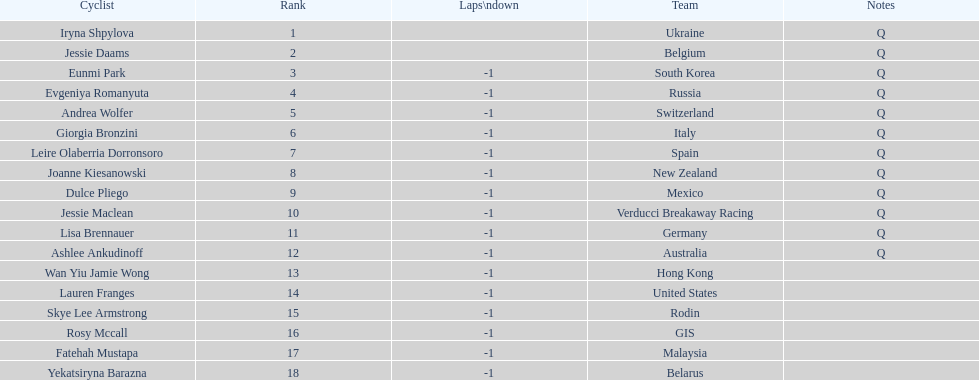How many cyclist do not have -1 laps down? 2. 